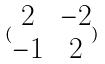<formula> <loc_0><loc_0><loc_500><loc_500>( \begin{matrix} 2 & - 2 \\ - 1 & 2 \end{matrix} )</formula> 